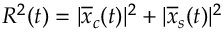<formula> <loc_0><loc_0><loc_500><loc_500>R ^ { 2 } ( t ) = | \overline { x } _ { c } ( t ) | ^ { 2 } + | \overline { x } _ { s } ( t ) | ^ { 2 }</formula> 